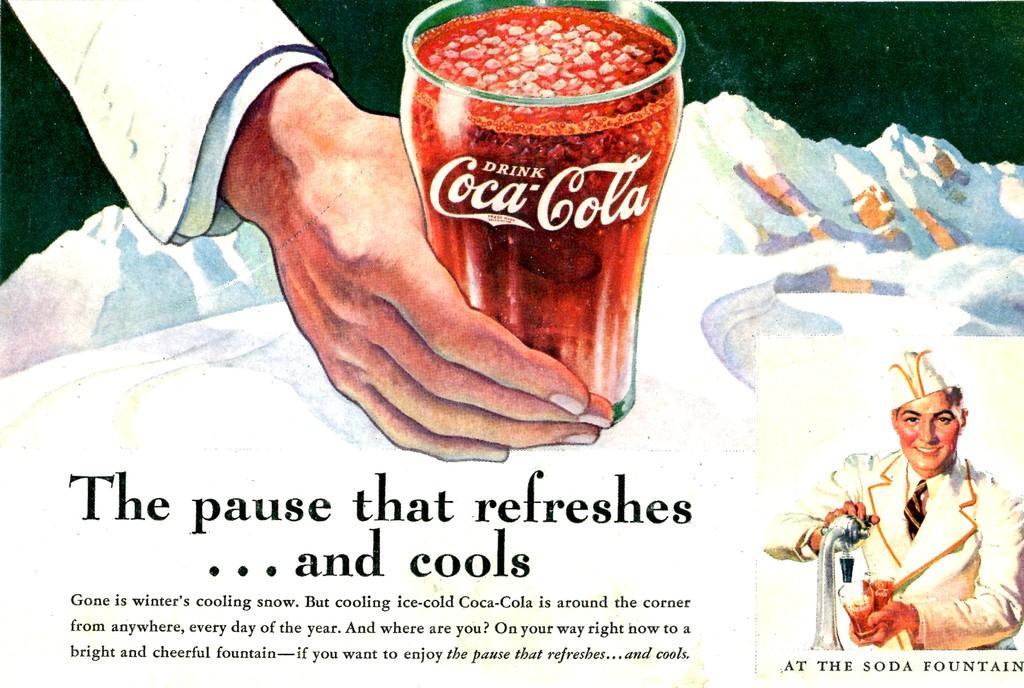In one or two sentences, can you explain what this image depicts? In this picture I can see a man who is holding a glass and a thing in his hands and I see that he is smiling. On the top of this picture I can see a person's hand, who is holding a glass and on the glass I see few words written. On the bottom of this picture I see few words written and I see that this is a depiction picture. 